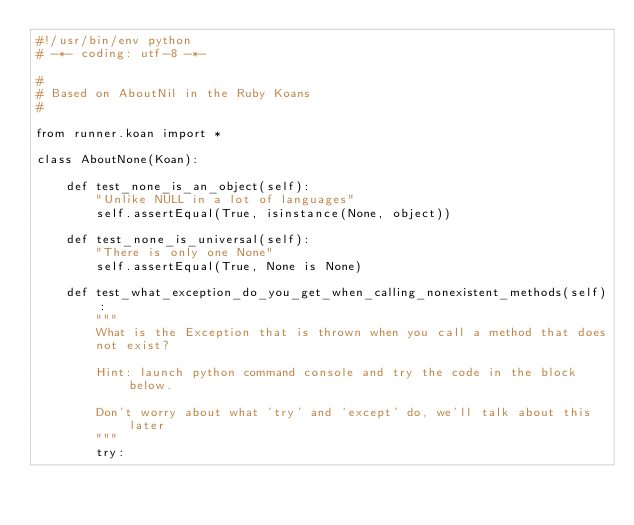<code> <loc_0><loc_0><loc_500><loc_500><_Python_>#!/usr/bin/env python
# -*- coding: utf-8 -*-

#
# Based on AboutNil in the Ruby Koans
#

from runner.koan import *

class AboutNone(Koan):

    def test_none_is_an_object(self):
        "Unlike NULL in a lot of languages"
        self.assertEqual(True, isinstance(None, object))

    def test_none_is_universal(self):
        "There is only one None"
        self.assertEqual(True, None is None)

    def test_what_exception_do_you_get_when_calling_nonexistent_methods(self):
        """
        What is the Exception that is thrown when you call a method that does
        not exist?

        Hint: launch python command console and try the code in the block below.

        Don't worry about what 'try' and 'except' do, we'll talk about this later
        """
        try:</code> 